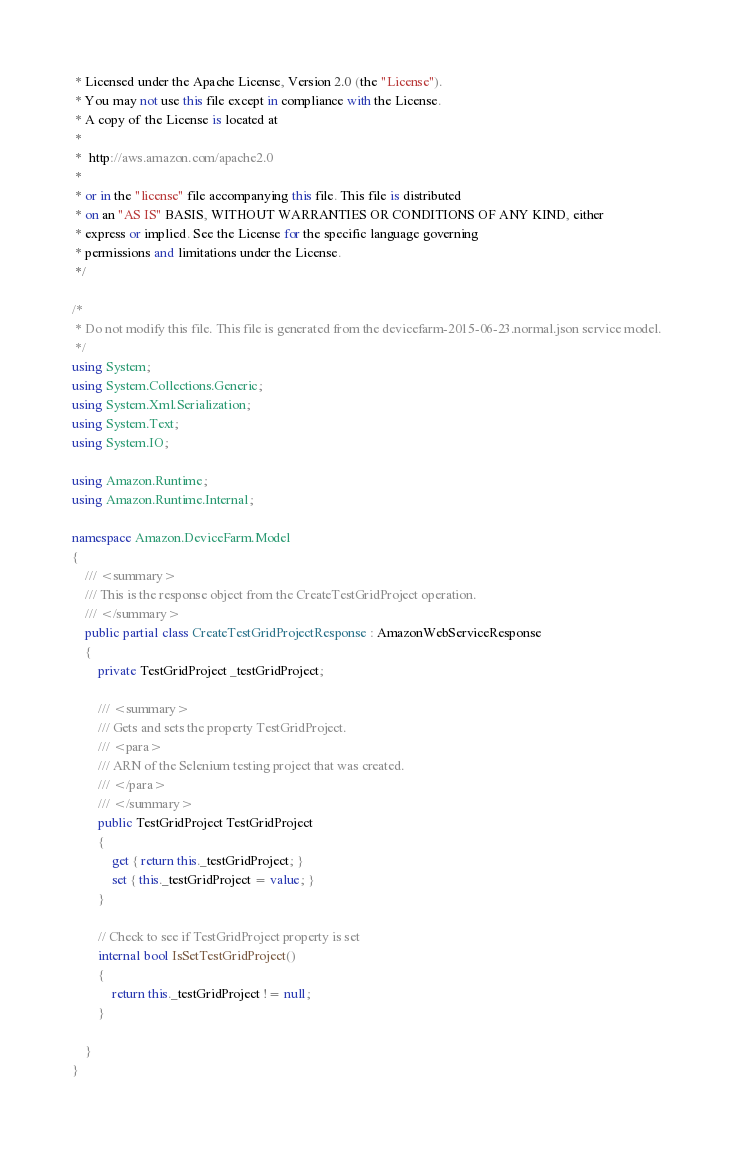<code> <loc_0><loc_0><loc_500><loc_500><_C#_> * Licensed under the Apache License, Version 2.0 (the "License").
 * You may not use this file except in compliance with the License.
 * A copy of the License is located at
 * 
 *  http://aws.amazon.com/apache2.0
 * 
 * or in the "license" file accompanying this file. This file is distributed
 * on an "AS IS" BASIS, WITHOUT WARRANTIES OR CONDITIONS OF ANY KIND, either
 * express or implied. See the License for the specific language governing
 * permissions and limitations under the License.
 */

/*
 * Do not modify this file. This file is generated from the devicefarm-2015-06-23.normal.json service model.
 */
using System;
using System.Collections.Generic;
using System.Xml.Serialization;
using System.Text;
using System.IO;

using Amazon.Runtime;
using Amazon.Runtime.Internal;

namespace Amazon.DeviceFarm.Model
{
    /// <summary>
    /// This is the response object from the CreateTestGridProject operation.
    /// </summary>
    public partial class CreateTestGridProjectResponse : AmazonWebServiceResponse
    {
        private TestGridProject _testGridProject;

        /// <summary>
        /// Gets and sets the property TestGridProject. 
        /// <para>
        /// ARN of the Selenium testing project that was created.
        /// </para>
        /// </summary>
        public TestGridProject TestGridProject
        {
            get { return this._testGridProject; }
            set { this._testGridProject = value; }
        }

        // Check to see if TestGridProject property is set
        internal bool IsSetTestGridProject()
        {
            return this._testGridProject != null;
        }

    }
}</code> 